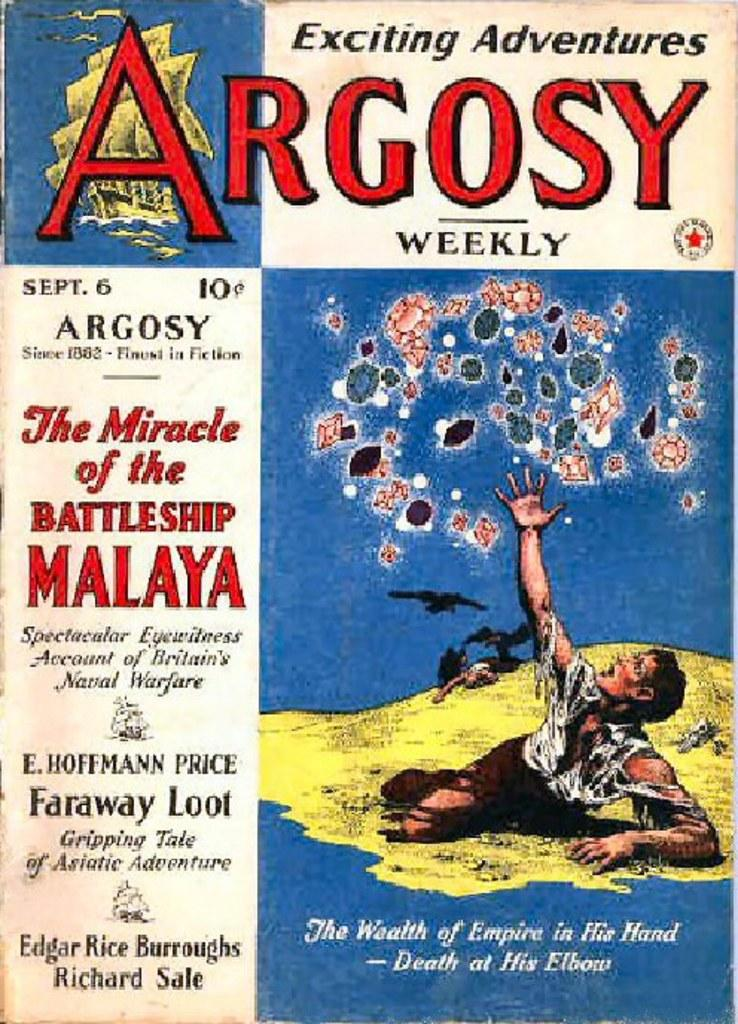<image>
Share a concise interpretation of the image provided. Exciting Adventures Argosy weekly book including The Miracle of the Battleship Malaya. 